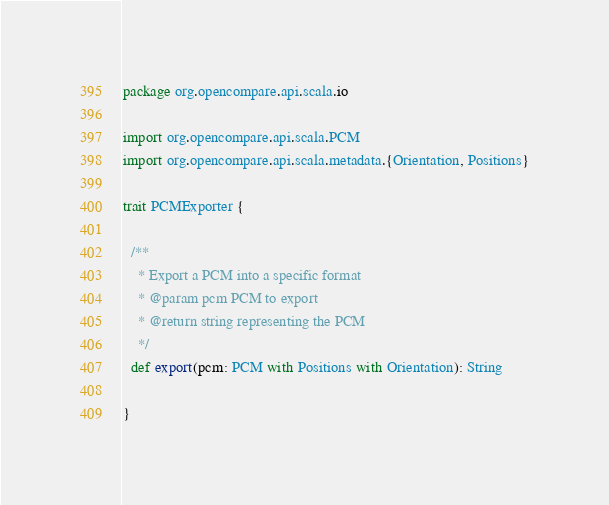<code> <loc_0><loc_0><loc_500><loc_500><_Scala_>package org.opencompare.api.scala.io

import org.opencompare.api.scala.PCM
import org.opencompare.api.scala.metadata.{Orientation, Positions}

trait PCMExporter {

  /**
    * Export a PCM into a specific format
    * @param pcm PCM to export
    * @return string representing the PCM
    */
  def export(pcm: PCM with Positions with Orientation): String

}
</code> 